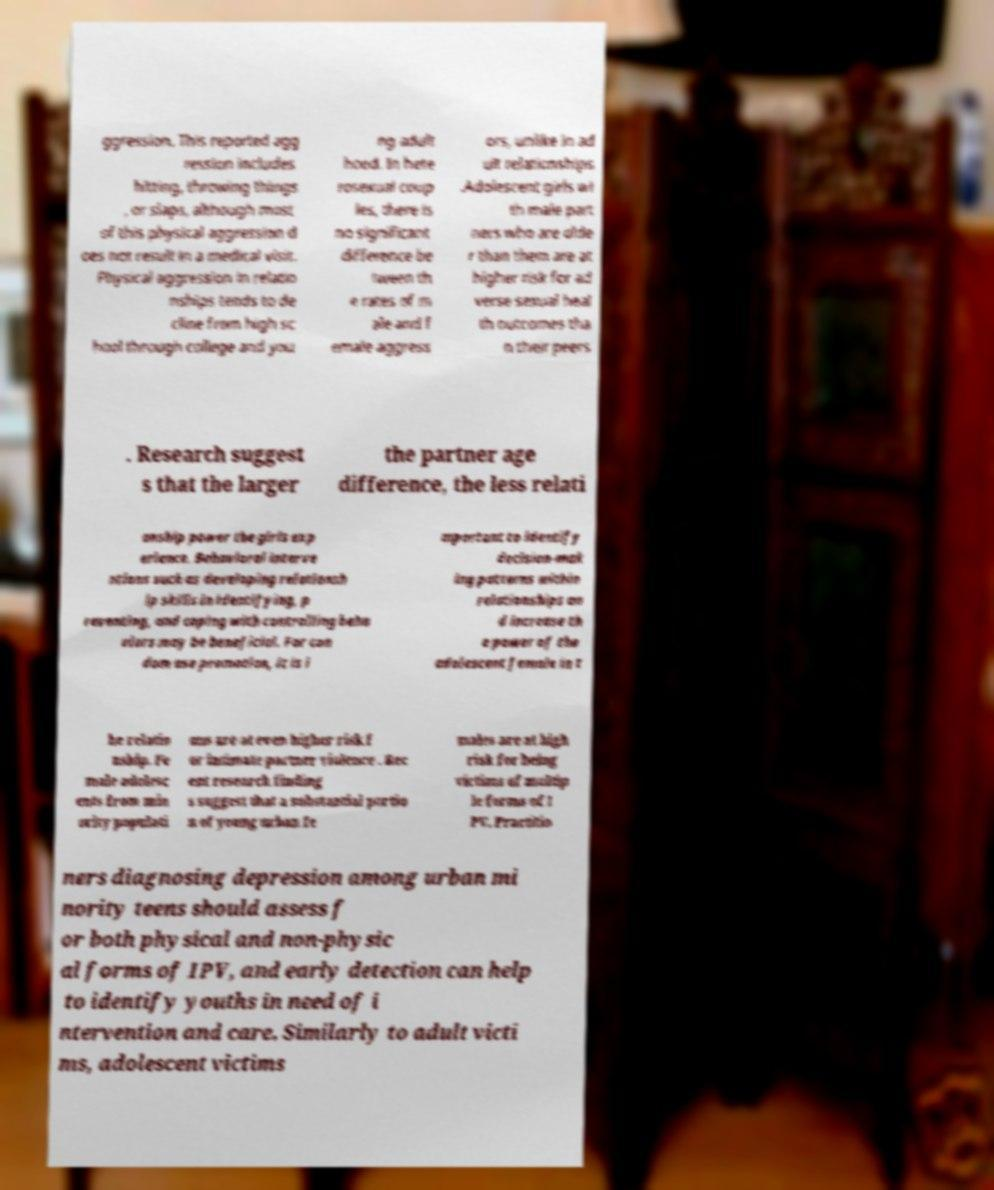There's text embedded in this image that I need extracted. Can you transcribe it verbatim? ggression. This reported agg ression includes hitting, throwing things , or slaps, although most of this physical aggression d oes not result in a medical visit. Physical aggression in relatio nships tends to de cline from high sc hool through college and you ng adult hood. In hete rosexual coup les, there is no significant difference be tween th e rates of m ale and f emale aggress ors, unlike in ad ult relationships .Adolescent girls wi th male part ners who are olde r than them are at higher risk for ad verse sexual heal th outcomes tha n their peers . Research suggest s that the larger the partner age difference, the less relati onship power the girls exp erience. Behavioral interve ntions such as developing relationsh ip skills in identifying, p reventing, and coping with controlling beha viors may be beneficial. For con dom use promotion, it is i mportant to identify decision-mak ing patterns within relationships an d increase th e power of the adolescent female in t he relatio nship. Fe male adolesc ents from min ority populati ons are at even higher risk f or intimate partner violence . Rec ent research finding s suggest that a substantial portio n of young urban fe males are at high risk for being victims of multip le forms of I PV. Practitio ners diagnosing depression among urban mi nority teens should assess f or both physical and non-physic al forms of IPV, and early detection can help to identify youths in need of i ntervention and care. Similarly to adult victi ms, adolescent victims 